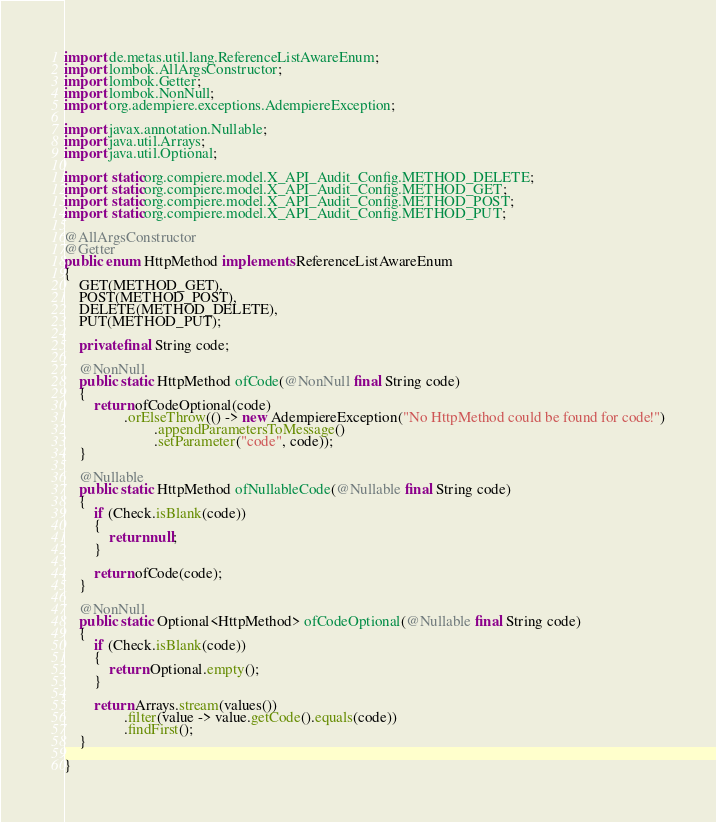Convert code to text. <code><loc_0><loc_0><loc_500><loc_500><_Java_>import de.metas.util.lang.ReferenceListAwareEnum;
import lombok.AllArgsConstructor;
import lombok.Getter;
import lombok.NonNull;
import org.adempiere.exceptions.AdempiereException;

import javax.annotation.Nullable;
import java.util.Arrays;
import java.util.Optional;

import static org.compiere.model.X_API_Audit_Config.METHOD_DELETE;
import static org.compiere.model.X_API_Audit_Config.METHOD_GET;
import static org.compiere.model.X_API_Audit_Config.METHOD_POST;
import static org.compiere.model.X_API_Audit_Config.METHOD_PUT;

@AllArgsConstructor
@Getter
public enum HttpMethod implements ReferenceListAwareEnum
{
	GET(METHOD_GET),
	POST(METHOD_POST),
	DELETE(METHOD_DELETE),
	PUT(METHOD_PUT);

	private final String code;

	@NonNull
	public static HttpMethod ofCode(@NonNull final String code)
	{
		return ofCodeOptional(code)
				.orElseThrow(() -> new AdempiereException("No HttpMethod could be found for code!")
						.appendParametersToMessage()
						.setParameter("code", code));
	}

	@Nullable
	public static HttpMethod ofNullableCode(@Nullable final String code)
	{
		if (Check.isBlank(code))
		{
			return null;
		}

		return ofCode(code);
	}

	@NonNull
	public static Optional<HttpMethod> ofCodeOptional(@Nullable final String code)
	{
		if (Check.isBlank(code))
		{
			return Optional.empty();
		}

		return Arrays.stream(values())
				.filter(value -> value.getCode().equals(code))
				.findFirst();
	}

}
</code> 